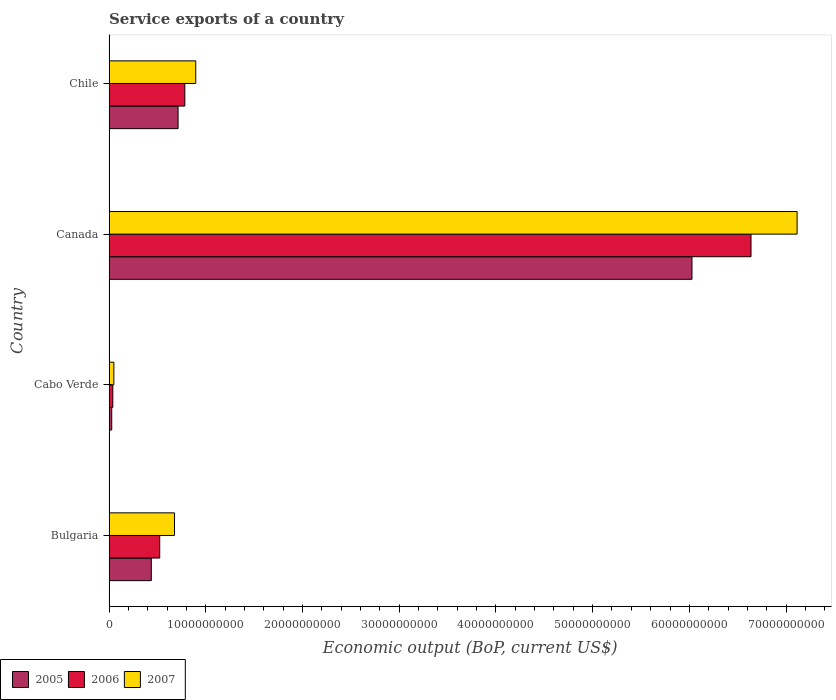How many bars are there on the 2nd tick from the bottom?
Your answer should be very brief. 3. What is the label of the 3rd group of bars from the top?
Your answer should be compact. Cabo Verde. What is the service exports in 2005 in Canada?
Provide a succinct answer. 6.03e+1. Across all countries, what is the maximum service exports in 2006?
Offer a very short reply. 6.64e+1. Across all countries, what is the minimum service exports in 2007?
Give a very brief answer. 4.96e+08. In which country was the service exports in 2007 maximum?
Your response must be concise. Canada. In which country was the service exports in 2007 minimum?
Your answer should be compact. Cabo Verde. What is the total service exports in 2006 in the graph?
Provide a succinct answer. 7.98e+1. What is the difference between the service exports in 2005 in Cabo Verde and that in Chile?
Offer a terse response. -6.86e+09. What is the difference between the service exports in 2007 in Cabo Verde and the service exports in 2005 in Bulgaria?
Provide a succinct answer. -3.87e+09. What is the average service exports in 2006 per country?
Provide a short and direct response. 2.00e+1. What is the difference between the service exports in 2006 and service exports in 2007 in Chile?
Your response must be concise. -1.13e+09. What is the ratio of the service exports in 2006 in Cabo Verde to that in Chile?
Give a very brief answer. 0.05. Is the difference between the service exports in 2006 in Bulgaria and Chile greater than the difference between the service exports in 2007 in Bulgaria and Chile?
Provide a short and direct response. No. What is the difference between the highest and the second highest service exports in 2006?
Keep it short and to the point. 5.85e+1. What is the difference between the highest and the lowest service exports in 2007?
Make the answer very short. 7.06e+1. Is the sum of the service exports in 2005 in Bulgaria and Cabo Verde greater than the maximum service exports in 2006 across all countries?
Offer a terse response. No. What does the 3rd bar from the bottom in Cabo Verde represents?
Offer a very short reply. 2007. How many bars are there?
Offer a very short reply. 12. What is the difference between two consecutive major ticks on the X-axis?
Offer a very short reply. 1.00e+1. Are the values on the major ticks of X-axis written in scientific E-notation?
Make the answer very short. No. Does the graph contain any zero values?
Give a very brief answer. No. How are the legend labels stacked?
Offer a terse response. Horizontal. What is the title of the graph?
Your answer should be compact. Service exports of a country. What is the label or title of the X-axis?
Offer a terse response. Economic output (BoP, current US$). What is the label or title of the Y-axis?
Make the answer very short. Country. What is the Economic output (BoP, current US$) of 2005 in Bulgaria?
Offer a very short reply. 4.37e+09. What is the Economic output (BoP, current US$) of 2006 in Bulgaria?
Your answer should be very brief. 5.24e+09. What is the Economic output (BoP, current US$) in 2007 in Bulgaria?
Your answer should be very brief. 6.76e+09. What is the Economic output (BoP, current US$) of 2005 in Cabo Verde?
Offer a terse response. 2.77e+08. What is the Economic output (BoP, current US$) in 2006 in Cabo Verde?
Provide a short and direct response. 3.86e+08. What is the Economic output (BoP, current US$) of 2007 in Cabo Verde?
Ensure brevity in your answer.  4.96e+08. What is the Economic output (BoP, current US$) in 2005 in Canada?
Your answer should be very brief. 6.03e+1. What is the Economic output (BoP, current US$) in 2006 in Canada?
Offer a terse response. 6.64e+1. What is the Economic output (BoP, current US$) in 2007 in Canada?
Give a very brief answer. 7.11e+1. What is the Economic output (BoP, current US$) in 2005 in Chile?
Your response must be concise. 7.13e+09. What is the Economic output (BoP, current US$) of 2006 in Chile?
Provide a short and direct response. 7.83e+09. What is the Economic output (BoP, current US$) in 2007 in Chile?
Make the answer very short. 8.96e+09. Across all countries, what is the maximum Economic output (BoP, current US$) of 2005?
Give a very brief answer. 6.03e+1. Across all countries, what is the maximum Economic output (BoP, current US$) in 2006?
Keep it short and to the point. 6.64e+1. Across all countries, what is the maximum Economic output (BoP, current US$) in 2007?
Make the answer very short. 7.11e+1. Across all countries, what is the minimum Economic output (BoP, current US$) in 2005?
Provide a short and direct response. 2.77e+08. Across all countries, what is the minimum Economic output (BoP, current US$) of 2006?
Give a very brief answer. 3.86e+08. Across all countries, what is the minimum Economic output (BoP, current US$) in 2007?
Your response must be concise. 4.96e+08. What is the total Economic output (BoP, current US$) of 2005 in the graph?
Offer a terse response. 7.21e+1. What is the total Economic output (BoP, current US$) of 2006 in the graph?
Make the answer very short. 7.98e+1. What is the total Economic output (BoP, current US$) of 2007 in the graph?
Ensure brevity in your answer.  8.74e+1. What is the difference between the Economic output (BoP, current US$) of 2005 in Bulgaria and that in Cabo Verde?
Provide a short and direct response. 4.09e+09. What is the difference between the Economic output (BoP, current US$) of 2006 in Bulgaria and that in Cabo Verde?
Give a very brief answer. 4.85e+09. What is the difference between the Economic output (BoP, current US$) of 2007 in Bulgaria and that in Cabo Verde?
Give a very brief answer. 6.27e+09. What is the difference between the Economic output (BoP, current US$) in 2005 in Bulgaria and that in Canada?
Your answer should be very brief. -5.59e+1. What is the difference between the Economic output (BoP, current US$) of 2006 in Bulgaria and that in Canada?
Keep it short and to the point. -6.11e+1. What is the difference between the Economic output (BoP, current US$) of 2007 in Bulgaria and that in Canada?
Keep it short and to the point. -6.44e+1. What is the difference between the Economic output (BoP, current US$) in 2005 in Bulgaria and that in Chile?
Keep it short and to the point. -2.77e+09. What is the difference between the Economic output (BoP, current US$) of 2006 in Bulgaria and that in Chile?
Ensure brevity in your answer.  -2.60e+09. What is the difference between the Economic output (BoP, current US$) in 2007 in Bulgaria and that in Chile?
Keep it short and to the point. -2.20e+09. What is the difference between the Economic output (BoP, current US$) of 2005 in Cabo Verde and that in Canada?
Provide a short and direct response. -6.00e+1. What is the difference between the Economic output (BoP, current US$) in 2006 in Cabo Verde and that in Canada?
Offer a terse response. -6.60e+1. What is the difference between the Economic output (BoP, current US$) in 2007 in Cabo Verde and that in Canada?
Your response must be concise. -7.06e+1. What is the difference between the Economic output (BoP, current US$) in 2005 in Cabo Verde and that in Chile?
Give a very brief answer. -6.86e+09. What is the difference between the Economic output (BoP, current US$) of 2006 in Cabo Verde and that in Chile?
Offer a very short reply. -7.45e+09. What is the difference between the Economic output (BoP, current US$) in 2007 in Cabo Verde and that in Chile?
Offer a very short reply. -8.47e+09. What is the difference between the Economic output (BoP, current US$) of 2005 in Canada and that in Chile?
Ensure brevity in your answer.  5.31e+1. What is the difference between the Economic output (BoP, current US$) in 2006 in Canada and that in Chile?
Ensure brevity in your answer.  5.85e+1. What is the difference between the Economic output (BoP, current US$) of 2007 in Canada and that in Chile?
Provide a succinct answer. 6.22e+1. What is the difference between the Economic output (BoP, current US$) of 2005 in Bulgaria and the Economic output (BoP, current US$) of 2006 in Cabo Verde?
Make the answer very short. 3.98e+09. What is the difference between the Economic output (BoP, current US$) in 2005 in Bulgaria and the Economic output (BoP, current US$) in 2007 in Cabo Verde?
Your response must be concise. 3.87e+09. What is the difference between the Economic output (BoP, current US$) of 2006 in Bulgaria and the Economic output (BoP, current US$) of 2007 in Cabo Verde?
Make the answer very short. 4.74e+09. What is the difference between the Economic output (BoP, current US$) of 2005 in Bulgaria and the Economic output (BoP, current US$) of 2006 in Canada?
Your response must be concise. -6.20e+1. What is the difference between the Economic output (BoP, current US$) of 2005 in Bulgaria and the Economic output (BoP, current US$) of 2007 in Canada?
Keep it short and to the point. -6.68e+1. What is the difference between the Economic output (BoP, current US$) of 2006 in Bulgaria and the Economic output (BoP, current US$) of 2007 in Canada?
Make the answer very short. -6.59e+1. What is the difference between the Economic output (BoP, current US$) of 2005 in Bulgaria and the Economic output (BoP, current US$) of 2006 in Chile?
Your answer should be very brief. -3.46e+09. What is the difference between the Economic output (BoP, current US$) in 2005 in Bulgaria and the Economic output (BoP, current US$) in 2007 in Chile?
Your answer should be very brief. -4.60e+09. What is the difference between the Economic output (BoP, current US$) in 2006 in Bulgaria and the Economic output (BoP, current US$) in 2007 in Chile?
Make the answer very short. -3.73e+09. What is the difference between the Economic output (BoP, current US$) in 2005 in Cabo Verde and the Economic output (BoP, current US$) in 2006 in Canada?
Give a very brief answer. -6.61e+1. What is the difference between the Economic output (BoP, current US$) of 2005 in Cabo Verde and the Economic output (BoP, current US$) of 2007 in Canada?
Keep it short and to the point. -7.09e+1. What is the difference between the Economic output (BoP, current US$) in 2006 in Cabo Verde and the Economic output (BoP, current US$) in 2007 in Canada?
Keep it short and to the point. -7.08e+1. What is the difference between the Economic output (BoP, current US$) of 2005 in Cabo Verde and the Economic output (BoP, current US$) of 2006 in Chile?
Make the answer very short. -7.56e+09. What is the difference between the Economic output (BoP, current US$) in 2005 in Cabo Verde and the Economic output (BoP, current US$) in 2007 in Chile?
Offer a very short reply. -8.69e+09. What is the difference between the Economic output (BoP, current US$) of 2006 in Cabo Verde and the Economic output (BoP, current US$) of 2007 in Chile?
Offer a very short reply. -8.58e+09. What is the difference between the Economic output (BoP, current US$) in 2005 in Canada and the Economic output (BoP, current US$) in 2006 in Chile?
Provide a succinct answer. 5.24e+1. What is the difference between the Economic output (BoP, current US$) in 2005 in Canada and the Economic output (BoP, current US$) in 2007 in Chile?
Provide a succinct answer. 5.13e+1. What is the difference between the Economic output (BoP, current US$) in 2006 in Canada and the Economic output (BoP, current US$) in 2007 in Chile?
Offer a very short reply. 5.74e+1. What is the average Economic output (BoP, current US$) of 2005 per country?
Your answer should be compact. 1.80e+1. What is the average Economic output (BoP, current US$) in 2006 per country?
Give a very brief answer. 2.00e+1. What is the average Economic output (BoP, current US$) in 2007 per country?
Provide a succinct answer. 2.18e+1. What is the difference between the Economic output (BoP, current US$) in 2005 and Economic output (BoP, current US$) in 2006 in Bulgaria?
Provide a short and direct response. -8.69e+08. What is the difference between the Economic output (BoP, current US$) of 2005 and Economic output (BoP, current US$) of 2007 in Bulgaria?
Give a very brief answer. -2.40e+09. What is the difference between the Economic output (BoP, current US$) in 2006 and Economic output (BoP, current US$) in 2007 in Bulgaria?
Offer a very short reply. -1.53e+09. What is the difference between the Economic output (BoP, current US$) of 2005 and Economic output (BoP, current US$) of 2006 in Cabo Verde?
Provide a short and direct response. -1.10e+08. What is the difference between the Economic output (BoP, current US$) of 2005 and Economic output (BoP, current US$) of 2007 in Cabo Verde?
Your answer should be very brief. -2.20e+08. What is the difference between the Economic output (BoP, current US$) in 2006 and Economic output (BoP, current US$) in 2007 in Cabo Verde?
Your answer should be compact. -1.10e+08. What is the difference between the Economic output (BoP, current US$) of 2005 and Economic output (BoP, current US$) of 2006 in Canada?
Keep it short and to the point. -6.10e+09. What is the difference between the Economic output (BoP, current US$) of 2005 and Economic output (BoP, current US$) of 2007 in Canada?
Your answer should be compact. -1.09e+1. What is the difference between the Economic output (BoP, current US$) of 2006 and Economic output (BoP, current US$) of 2007 in Canada?
Your answer should be compact. -4.76e+09. What is the difference between the Economic output (BoP, current US$) of 2005 and Economic output (BoP, current US$) of 2006 in Chile?
Offer a terse response. -6.97e+08. What is the difference between the Economic output (BoP, current US$) in 2005 and Economic output (BoP, current US$) in 2007 in Chile?
Provide a short and direct response. -1.83e+09. What is the difference between the Economic output (BoP, current US$) in 2006 and Economic output (BoP, current US$) in 2007 in Chile?
Offer a terse response. -1.13e+09. What is the ratio of the Economic output (BoP, current US$) of 2005 in Bulgaria to that in Cabo Verde?
Ensure brevity in your answer.  15.79. What is the ratio of the Economic output (BoP, current US$) of 2006 in Bulgaria to that in Cabo Verde?
Give a very brief answer. 13.55. What is the ratio of the Economic output (BoP, current US$) of 2007 in Bulgaria to that in Cabo Verde?
Offer a terse response. 13.63. What is the ratio of the Economic output (BoP, current US$) of 2005 in Bulgaria to that in Canada?
Give a very brief answer. 0.07. What is the ratio of the Economic output (BoP, current US$) of 2006 in Bulgaria to that in Canada?
Make the answer very short. 0.08. What is the ratio of the Economic output (BoP, current US$) in 2007 in Bulgaria to that in Canada?
Keep it short and to the point. 0.1. What is the ratio of the Economic output (BoP, current US$) of 2005 in Bulgaria to that in Chile?
Offer a very short reply. 0.61. What is the ratio of the Economic output (BoP, current US$) of 2006 in Bulgaria to that in Chile?
Your response must be concise. 0.67. What is the ratio of the Economic output (BoP, current US$) of 2007 in Bulgaria to that in Chile?
Keep it short and to the point. 0.75. What is the ratio of the Economic output (BoP, current US$) of 2005 in Cabo Verde to that in Canada?
Offer a terse response. 0. What is the ratio of the Economic output (BoP, current US$) of 2006 in Cabo Verde to that in Canada?
Your response must be concise. 0.01. What is the ratio of the Economic output (BoP, current US$) in 2007 in Cabo Verde to that in Canada?
Provide a succinct answer. 0.01. What is the ratio of the Economic output (BoP, current US$) of 2005 in Cabo Verde to that in Chile?
Provide a short and direct response. 0.04. What is the ratio of the Economic output (BoP, current US$) in 2006 in Cabo Verde to that in Chile?
Provide a succinct answer. 0.05. What is the ratio of the Economic output (BoP, current US$) in 2007 in Cabo Verde to that in Chile?
Provide a succinct answer. 0.06. What is the ratio of the Economic output (BoP, current US$) in 2005 in Canada to that in Chile?
Offer a terse response. 8.45. What is the ratio of the Economic output (BoP, current US$) in 2006 in Canada to that in Chile?
Provide a succinct answer. 8.47. What is the ratio of the Economic output (BoP, current US$) in 2007 in Canada to that in Chile?
Your response must be concise. 7.94. What is the difference between the highest and the second highest Economic output (BoP, current US$) in 2005?
Make the answer very short. 5.31e+1. What is the difference between the highest and the second highest Economic output (BoP, current US$) in 2006?
Ensure brevity in your answer.  5.85e+1. What is the difference between the highest and the second highest Economic output (BoP, current US$) of 2007?
Give a very brief answer. 6.22e+1. What is the difference between the highest and the lowest Economic output (BoP, current US$) in 2005?
Offer a very short reply. 6.00e+1. What is the difference between the highest and the lowest Economic output (BoP, current US$) in 2006?
Offer a terse response. 6.60e+1. What is the difference between the highest and the lowest Economic output (BoP, current US$) in 2007?
Your response must be concise. 7.06e+1. 